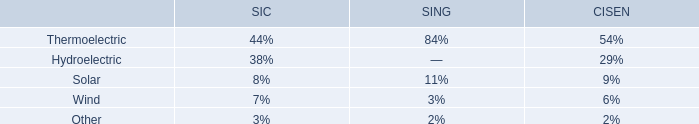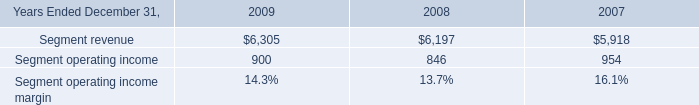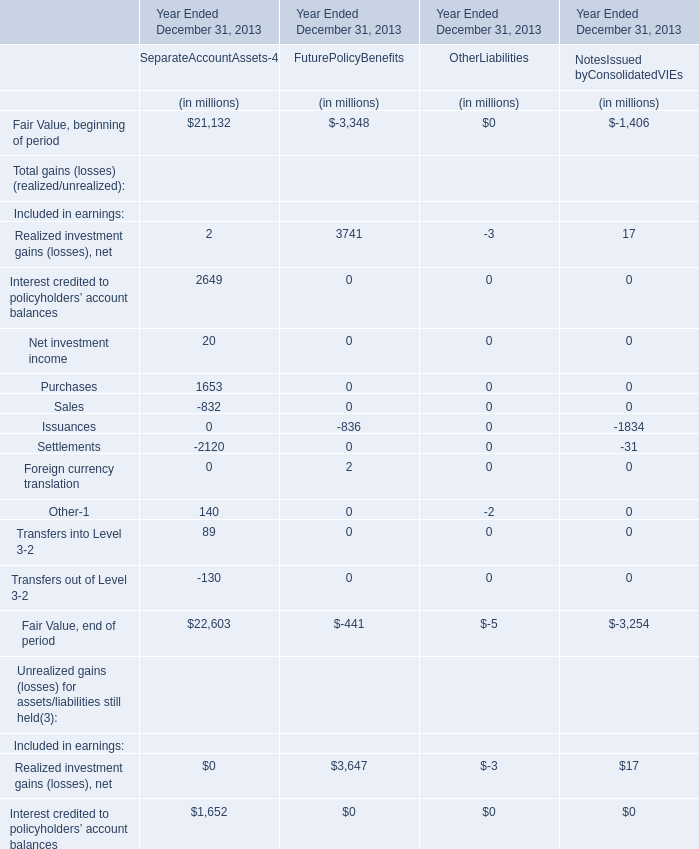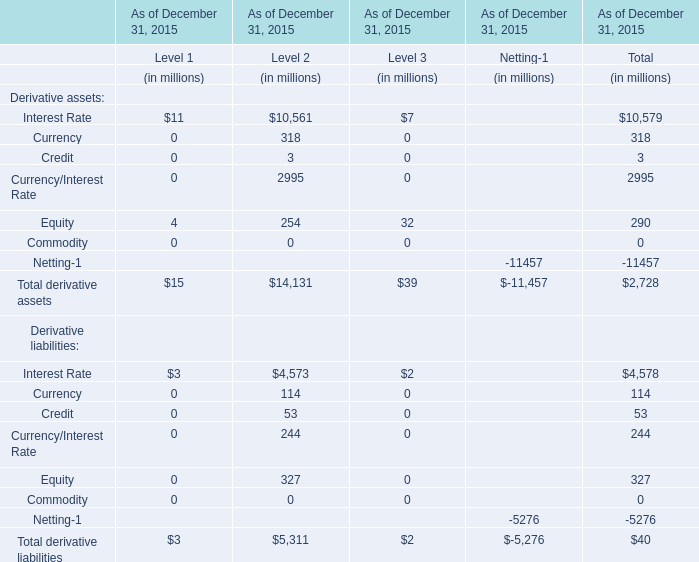Which Level is Total derivative assets as of December 31, 2015 the largest? 
Answer: 2. 